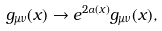Convert formula to latex. <formula><loc_0><loc_0><loc_500><loc_500>g _ { \mu \nu } ( x ) \rightarrow e ^ { 2 \alpha ( x ) } g _ { \mu \nu } ( x ) ,</formula> 